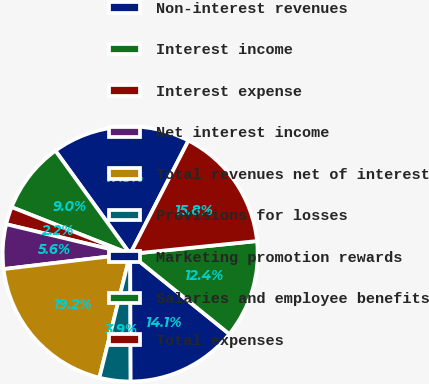Convert chart to OTSL. <chart><loc_0><loc_0><loc_500><loc_500><pie_chart><fcel>Non-interest revenues<fcel>Interest income<fcel>Interest expense<fcel>Net interest income<fcel>Total revenues net of interest<fcel>Provisions for losses<fcel>Marketing promotion rewards<fcel>Salaries and employee benefits<fcel>Total expenses<nl><fcel>17.53%<fcel>9.04%<fcel>2.24%<fcel>5.64%<fcel>19.23%<fcel>3.94%<fcel>14.13%<fcel>12.43%<fcel>15.83%<nl></chart> 